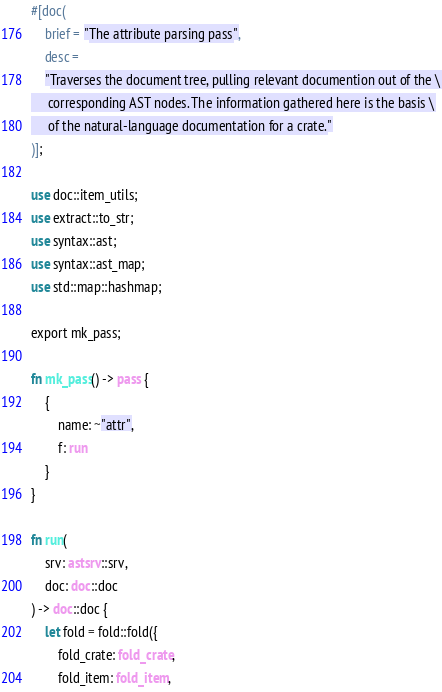Convert code to text. <code><loc_0><loc_0><loc_500><loc_500><_Rust_>#[doc(
    brief = "The attribute parsing pass",
    desc =
    "Traverses the document tree, pulling relevant documention out of the \
     corresponding AST nodes. The information gathered here is the basis \
     of the natural-language documentation for a crate."
)];

use doc::item_utils;
use extract::to_str;
use syntax::ast;
use syntax::ast_map;
use std::map::hashmap;

export mk_pass;

fn mk_pass() -> pass {
    {
        name: ~"attr",
        f: run
    }
}

fn run(
    srv: astsrv::srv,
    doc: doc::doc
) -> doc::doc {
    let fold = fold::fold({
        fold_crate: fold_crate,
        fold_item: fold_item,</code> 